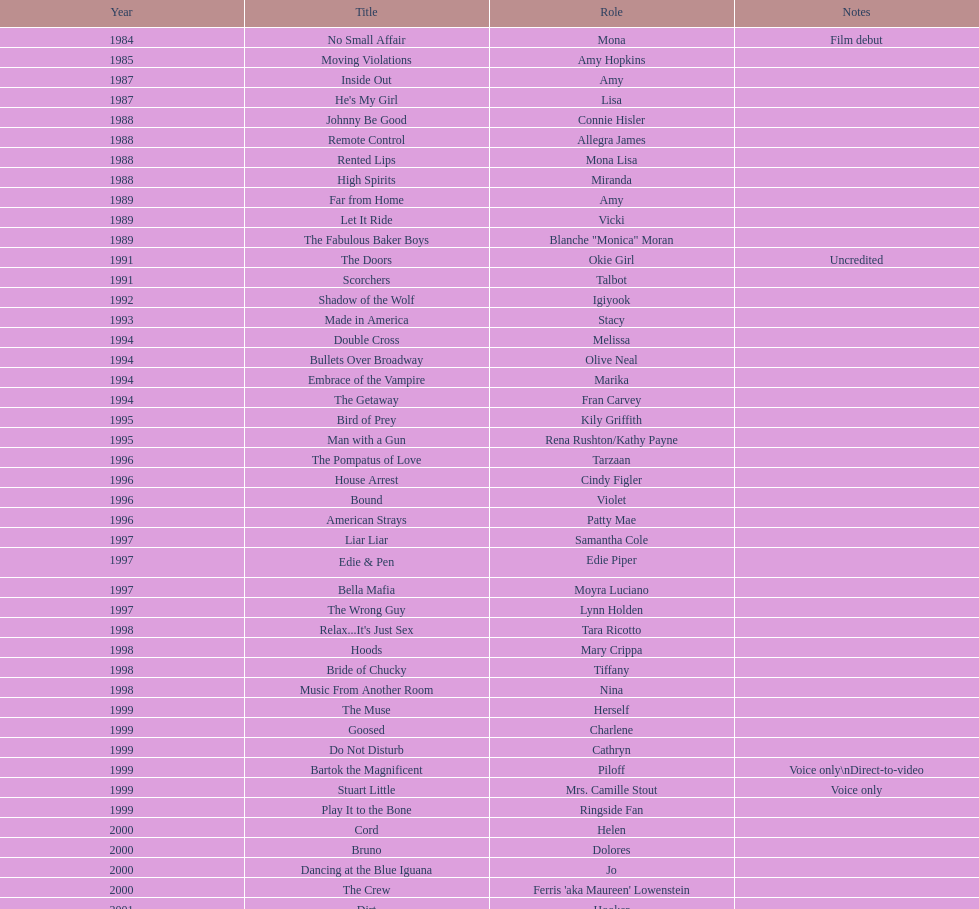Which year had the most credits? 2004. 